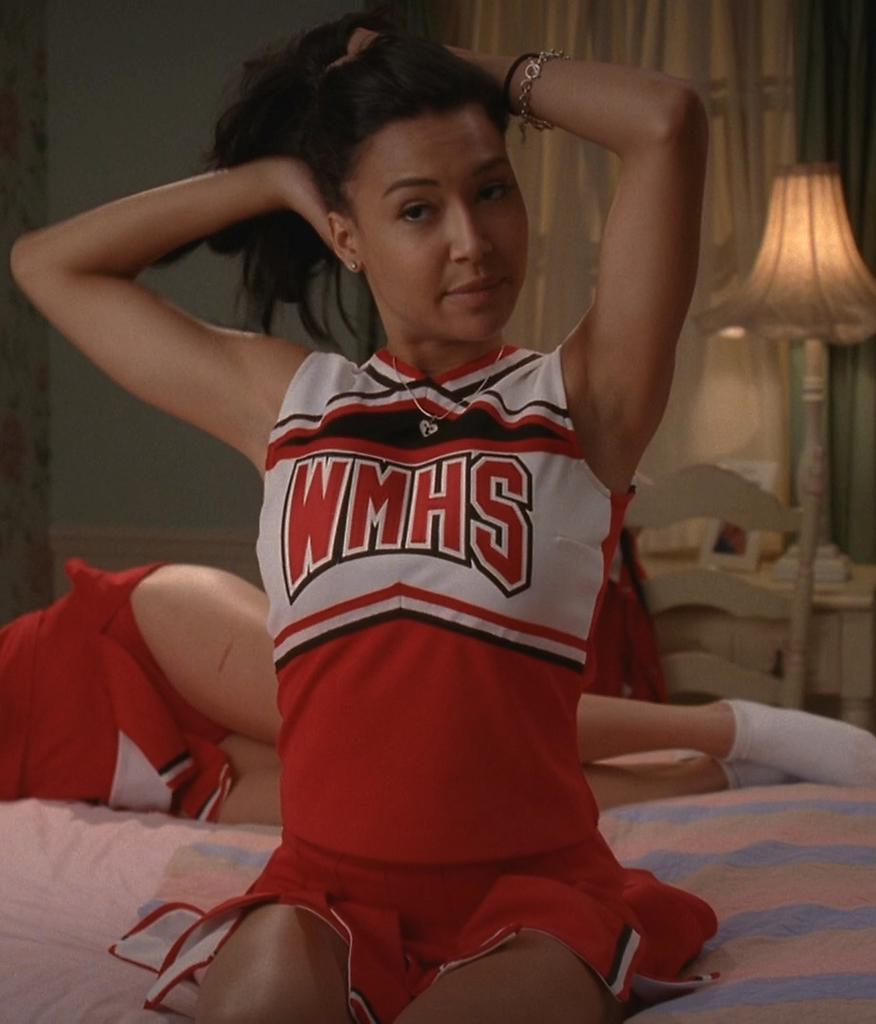<image>
Provide a brief description of the given image. a cheerleader that has WMHS on their outfit 